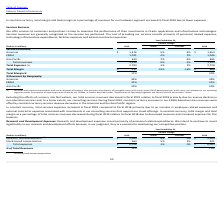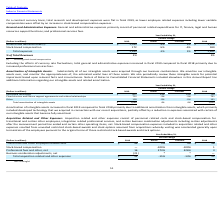Looking at Oracle Corporation's financial data, please calculate: How much more was the research and development expenses in 2018 compared to 2019? Based on the calculation: 5,163 - 5,063 , the result is 100 (in millions). This is based on the information: "research and development (1) $ 5,063 -2% 0% $ 5,163 research and development (1) $ 5,063 -2% 0% $ 5,163..." The key data points involved are: 5,063, 5,163. Also, can you calculate: What is the percentage of expenses that went towards stock-based compensation in 2019? Based on the calculation: 963/6,026 , the result is 15.98 (percentage). This is based on the information: "Total expenses $ 6,026 -1% 0% $ 6,084 Stock-based compensation 963 5% 5% 921..." The key data points involved are: 6,026, 963. Also, can you calculate: What was the difference in total expenses in 2019 relative to 2018? Based on the calculation: 6,026 -6,084, the result is -58 (in millions). This is based on the information: "Total expenses $ 6,026 -1% 0% $ 6,084 Total expenses $ 6,026 -1% 0% $ 6,084..." The key data points involved are: 6,026, 6,084. Also, What is the primary component of Research and development expenses? Research and development expenses consist primarily of personnel related expenditures.. The document states: "Research and Development Expenses: research and development expenses consist primarily of personnel related expenditures. We intend to continue to inv..." Also, Does the company intend to continue to invest significantly in Research and Development? We intend to continue to invest significantly in our research and development efforts. The document states: "sist primarily of personnel related expenditures. We intend to continue to invest significantly in our research and development efforts because, in ou..." Also, Why was the total research and development expenses flat in fiscal 2019? On a constant currency basis, total research and development expenses were flat in fiscal 2019, as lower employee related expenses including lower variable compensation were offset by an increase in stock-based compensation expenses .. The document states: "On a constant currency basis, total research and development expenses were flat in fiscal 2019, as lower employee related expenses including lower var..." 